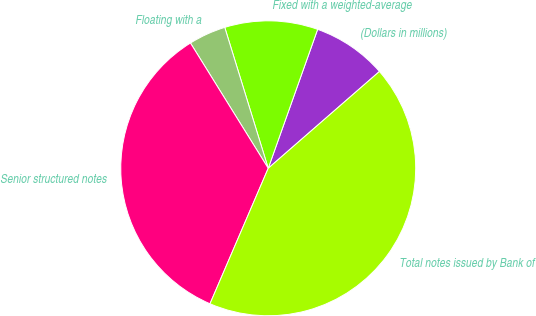Convert chart. <chart><loc_0><loc_0><loc_500><loc_500><pie_chart><fcel>(Dollars in millions)<fcel>Fixed with a weighted-average<fcel>Floating with a<fcel>Senior structured notes<fcel>Total notes issued by Bank of<nl><fcel>8.16%<fcel>10.2%<fcel>4.08%<fcel>34.69%<fcel>42.86%<nl></chart> 